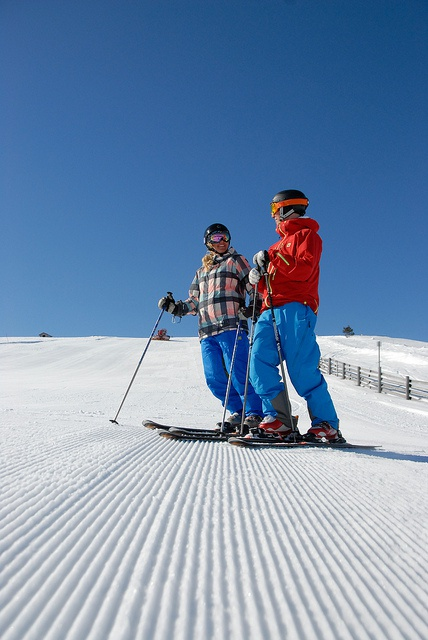Describe the objects in this image and their specific colors. I can see people in blue, maroon, and black tones, people in blue, black, navy, gray, and darkblue tones, skis in blue, black, gray, and lightgray tones, and skis in blue, black, gray, darkgray, and lightgray tones in this image. 